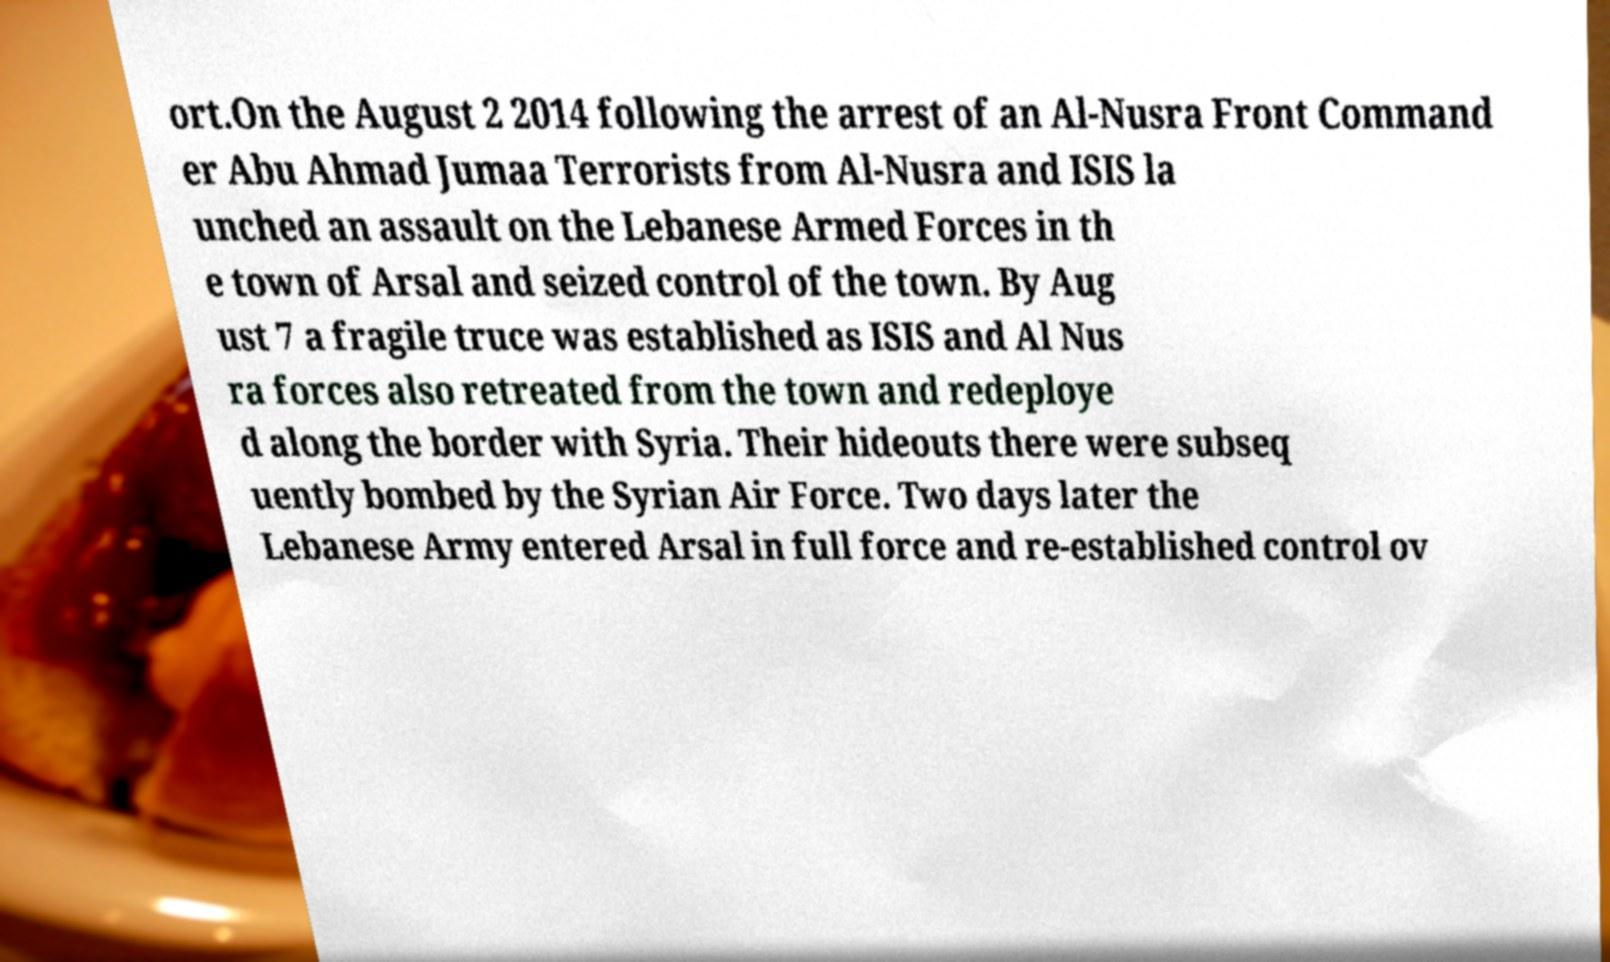Can you accurately transcribe the text from the provided image for me? ort.On the August 2 2014 following the arrest of an Al-Nusra Front Command er Abu Ahmad Jumaa Terrorists from Al-Nusra and ISIS la unched an assault on the Lebanese Armed Forces in th e town of Arsal and seized control of the town. By Aug ust 7 a fragile truce was established as ISIS and Al Nus ra forces also retreated from the town and redeploye d along the border with Syria. Their hideouts there were subseq uently bombed by the Syrian Air Force. Two days later the Lebanese Army entered Arsal in full force and re-established control ov 